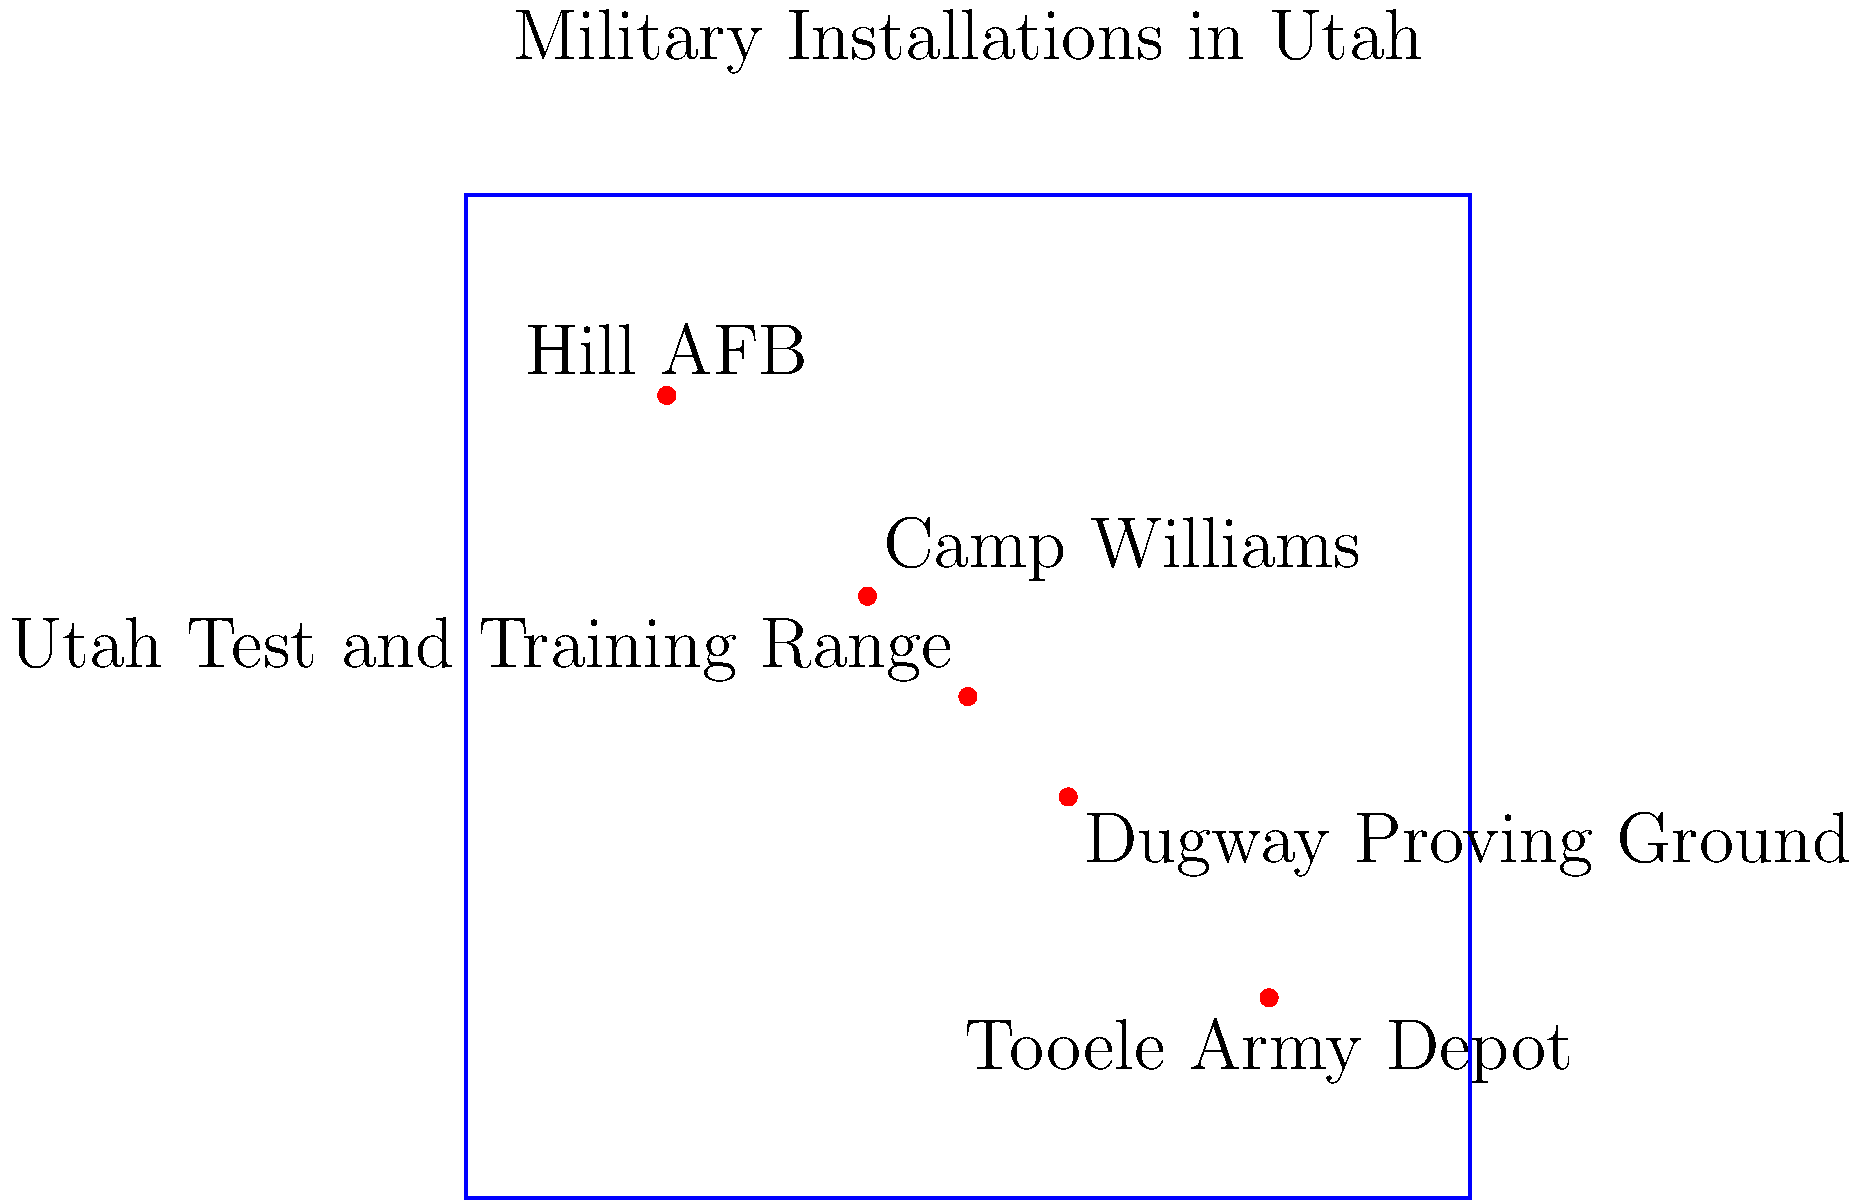Based on the geographical distribution of military installations shown on the Utah state map, which installation is located closest to the center of the state and likely plays a crucial role in coordinating activities across other bases? To determine which military installation is closest to the center of Utah and likely plays a crucial role in coordinating activities, we need to follow these steps:

1. Identify the approximate center of the state on the map. In this simplified representation, it would be around the point (50,50).

2. Locate all military installations on the map:
   a. Hill AFB: top-left corner
   b. Camp Williams: upper-middle area
   c. Dugway Proving Ground: lower-middle area
   d. Tooele Army Depot: bottom-right corner
   e. Utah Test and Training Range: center of the map

3. Compare the positions of each installation to the center point:
   - Hill AFB and Tooele Army Depot are furthest from the center.
   - Camp Williams and Dugway Proving Ground are closer but still off-center.
   - Utah Test and Training Range is located almost exactly in the center.

4. Consider the nature of the centrally located installation:
   - The Utah Test and Training Range, being in the center, would have the best geographical position for coordinating activities across other bases.
   - Its name suggests it's used for testing and training, which often involves coordination with other military facilities.

5. Conclude that the Utah Test and Training Range, due to its central location and nature of operations, is most likely to play a crucial role in coordinating activities across other bases in Utah.
Answer: Utah Test and Training Range 